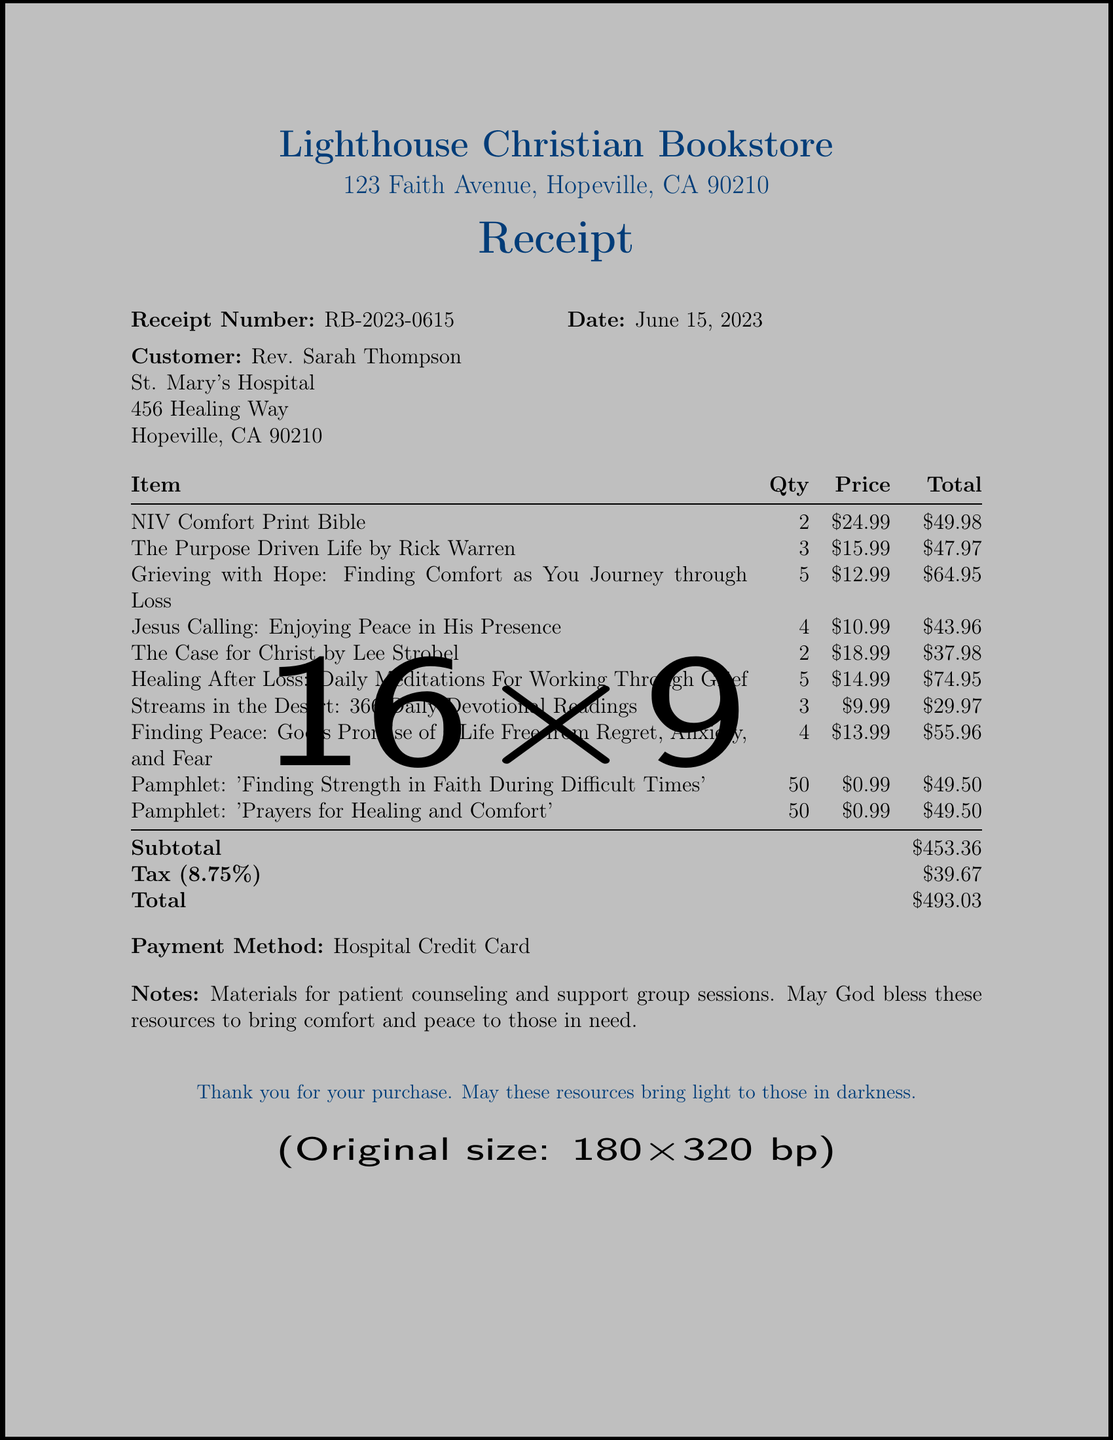What is the receipt number? The receipt number is specifically listed in the document and helps identify this transaction.
Answer: RB-2023-0615 Who is the customer? The document names the individual or entity who made the purchase, which is crucial for records.
Answer: Rev. Sarah Thompson What is the date of the purchase? The date indicates when the transaction occurred, which is important for accounting and record-keeping.
Answer: June 15, 2023 How many copies of "Grieving with Hope" were purchased? The quantity of this specific item indicates how many were bought for counseling purposes.
Answer: 5 What is the subtotal amount? The subtotal provides a sum of all items before tax, reflecting the actual purchases made.
Answer: $453.36 What is the tax amount charged? Understanding the tax helps in calculating the total expense for budgeting and accounting purposes.
Answer: $39.67 What payment method was used? Knowing the payment method gives insight into how the purchase was financed or recorded in accounts.
Answer: Hospital Credit Card What is the total amount paid? The total amount is the final figure, inclusive of tax, which the customer is responsible for paying.
Answer: $493.03 What is the vendor's name? The vendor is the business where the purchase was made, essential for recognizing where resources were obtained.
Answer: Lighthouse Christian Bookstore 